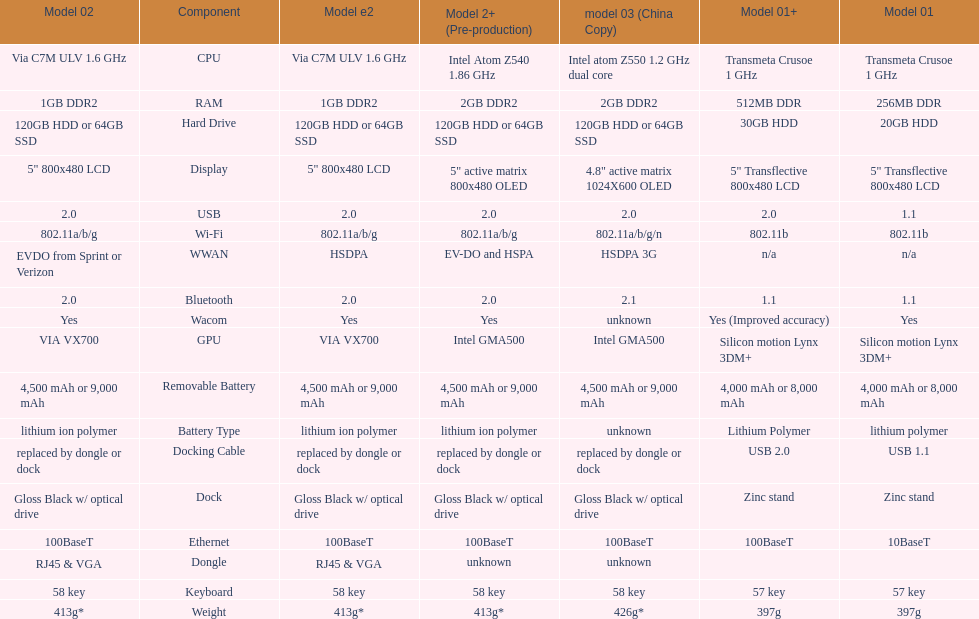How many models have 1.6ghz? 2. 